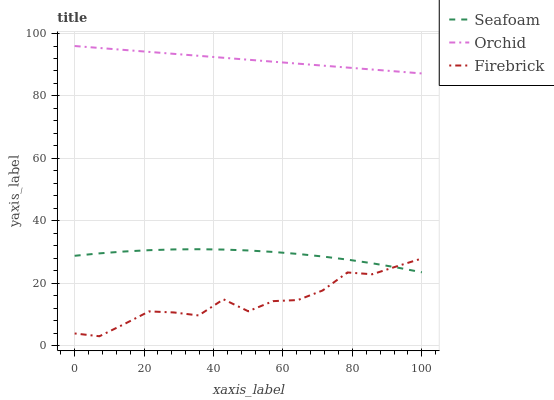Does Firebrick have the minimum area under the curve?
Answer yes or no. Yes. Does Orchid have the maximum area under the curve?
Answer yes or no. Yes. Does Seafoam have the minimum area under the curve?
Answer yes or no. No. Does Seafoam have the maximum area under the curve?
Answer yes or no. No. Is Orchid the smoothest?
Answer yes or no. Yes. Is Firebrick the roughest?
Answer yes or no. Yes. Is Seafoam the smoothest?
Answer yes or no. No. Is Seafoam the roughest?
Answer yes or no. No. Does Firebrick have the lowest value?
Answer yes or no. Yes. Does Seafoam have the lowest value?
Answer yes or no. No. Does Orchid have the highest value?
Answer yes or no. Yes. Does Seafoam have the highest value?
Answer yes or no. No. Is Seafoam less than Orchid?
Answer yes or no. Yes. Is Orchid greater than Seafoam?
Answer yes or no. Yes. Does Seafoam intersect Firebrick?
Answer yes or no. Yes. Is Seafoam less than Firebrick?
Answer yes or no. No. Is Seafoam greater than Firebrick?
Answer yes or no. No. Does Seafoam intersect Orchid?
Answer yes or no. No. 